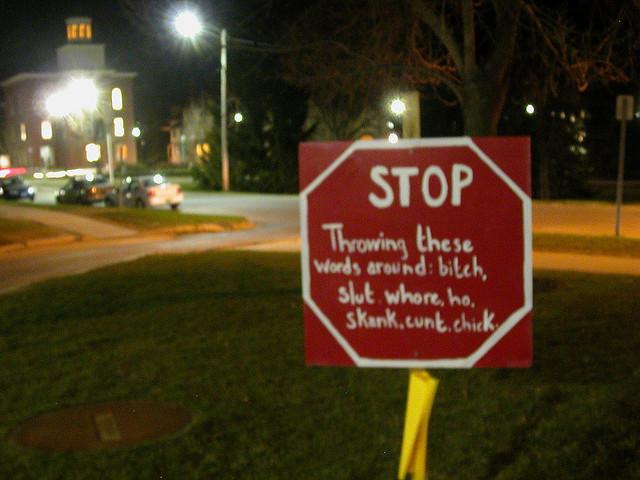Is this a regular stop sign?
Quick response, please. No. What color is the sign?
Concise answer only. Red. Does this look like an action shot?
Be succinct. No. Could these signs be in-appropriate?
Be succinct. Yes. Was this photo taken in the daytime?
Short answer required. No. Does the sign say stop?
Give a very brief answer. Yes. 